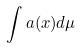Convert formula to latex. <formula><loc_0><loc_0><loc_500><loc_500>\int a ( x ) d \mu</formula> 